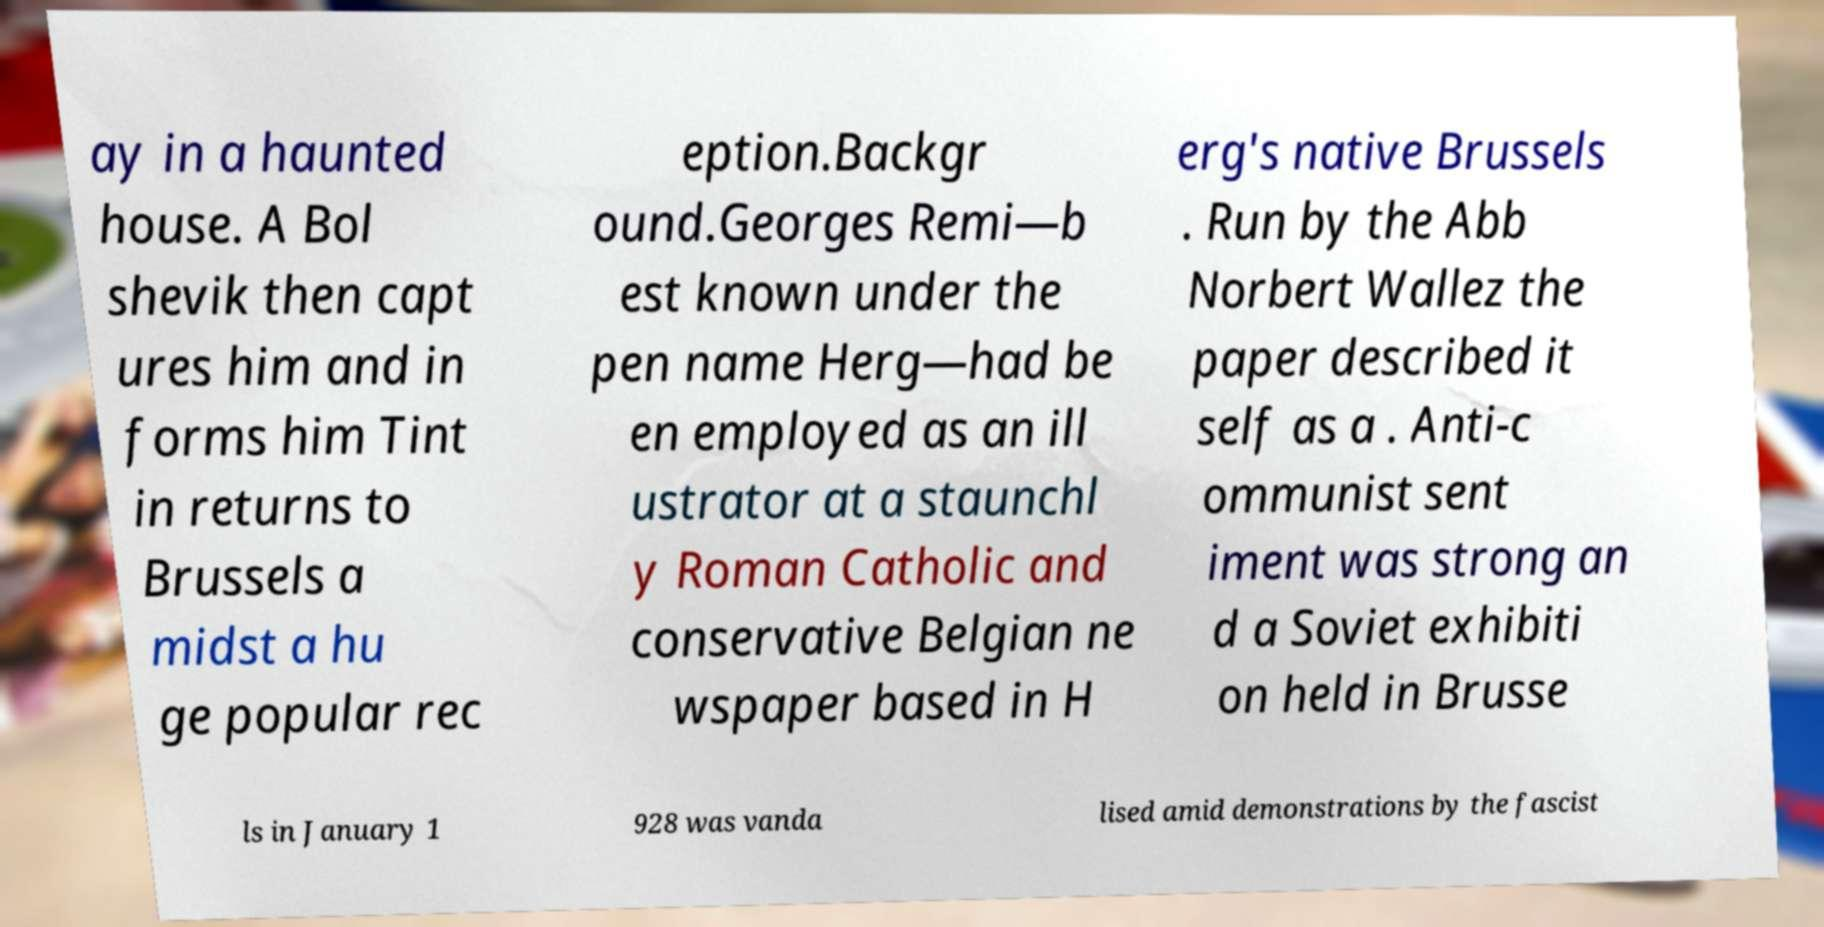Can you accurately transcribe the text from the provided image for me? ay in a haunted house. A Bol shevik then capt ures him and in forms him Tint in returns to Brussels a midst a hu ge popular rec eption.Backgr ound.Georges Remi—b est known under the pen name Herg—had be en employed as an ill ustrator at a staunchl y Roman Catholic and conservative Belgian ne wspaper based in H erg's native Brussels . Run by the Abb Norbert Wallez the paper described it self as a . Anti-c ommunist sent iment was strong an d a Soviet exhibiti on held in Brusse ls in January 1 928 was vanda lised amid demonstrations by the fascist 